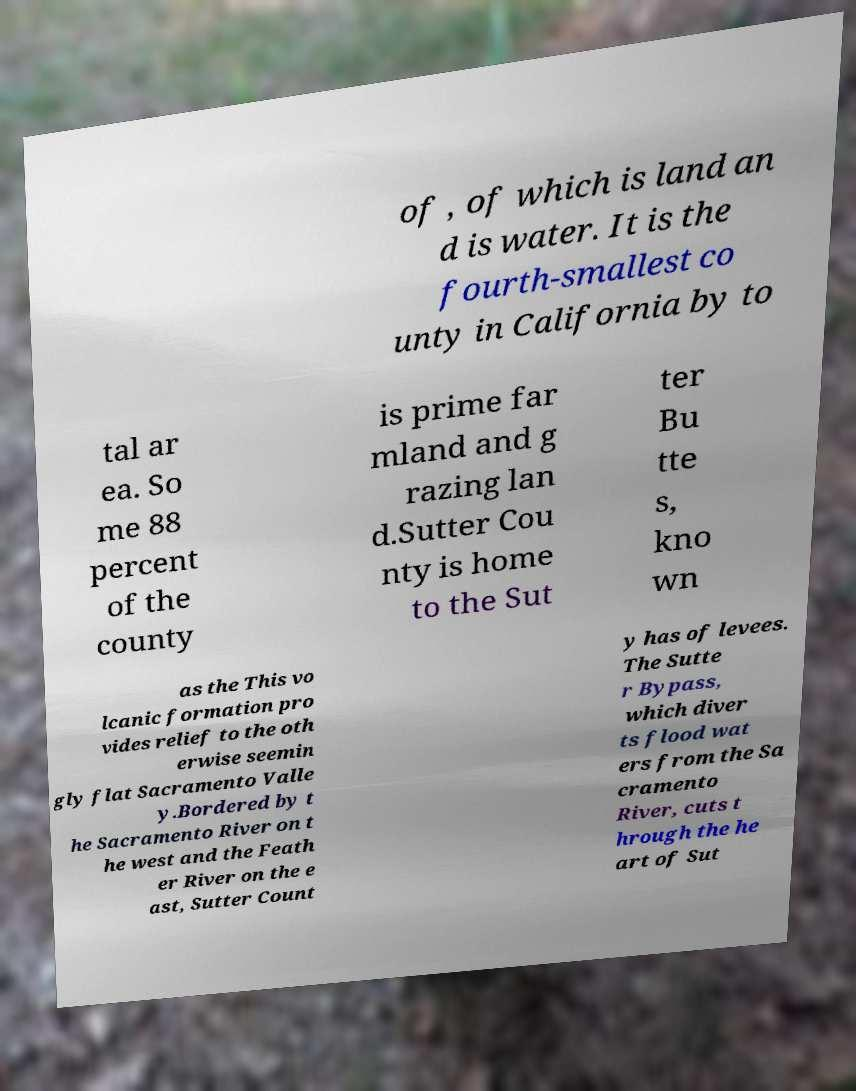Can you accurately transcribe the text from the provided image for me? of , of which is land an d is water. It is the fourth-smallest co unty in California by to tal ar ea. So me 88 percent of the county is prime far mland and g razing lan d.Sutter Cou nty is home to the Sut ter Bu tte s, kno wn as the This vo lcanic formation pro vides relief to the oth erwise seemin gly flat Sacramento Valle y.Bordered by t he Sacramento River on t he west and the Feath er River on the e ast, Sutter Count y has of levees. The Sutte r Bypass, which diver ts flood wat ers from the Sa cramento River, cuts t hrough the he art of Sut 